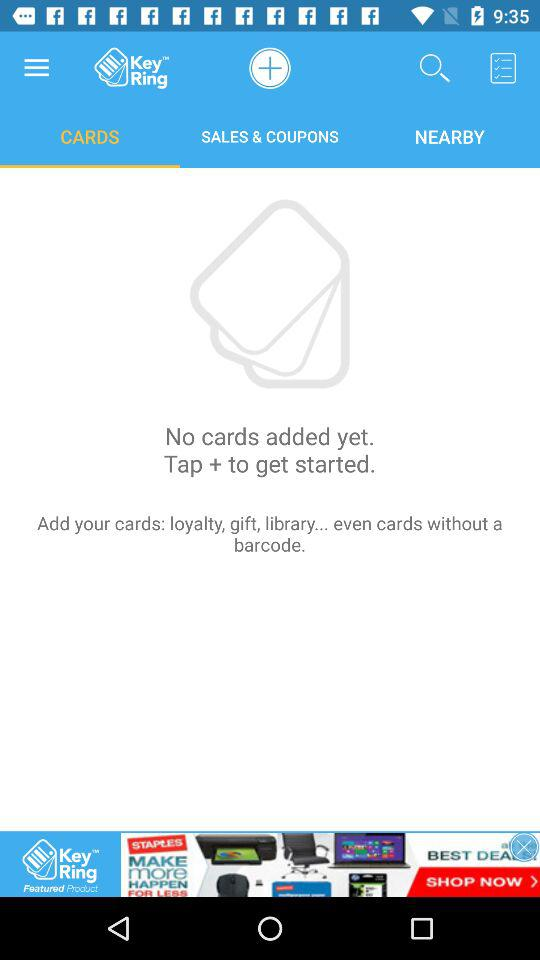How many cards are in the user's account?
Answer the question using a single word or phrase. 0 